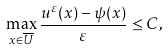<formula> <loc_0><loc_0><loc_500><loc_500>\max _ { x \in \overline { U } } \frac { u ^ { \varepsilon } ( x ) - \psi ( x ) } { \varepsilon } \leq C ,</formula> 